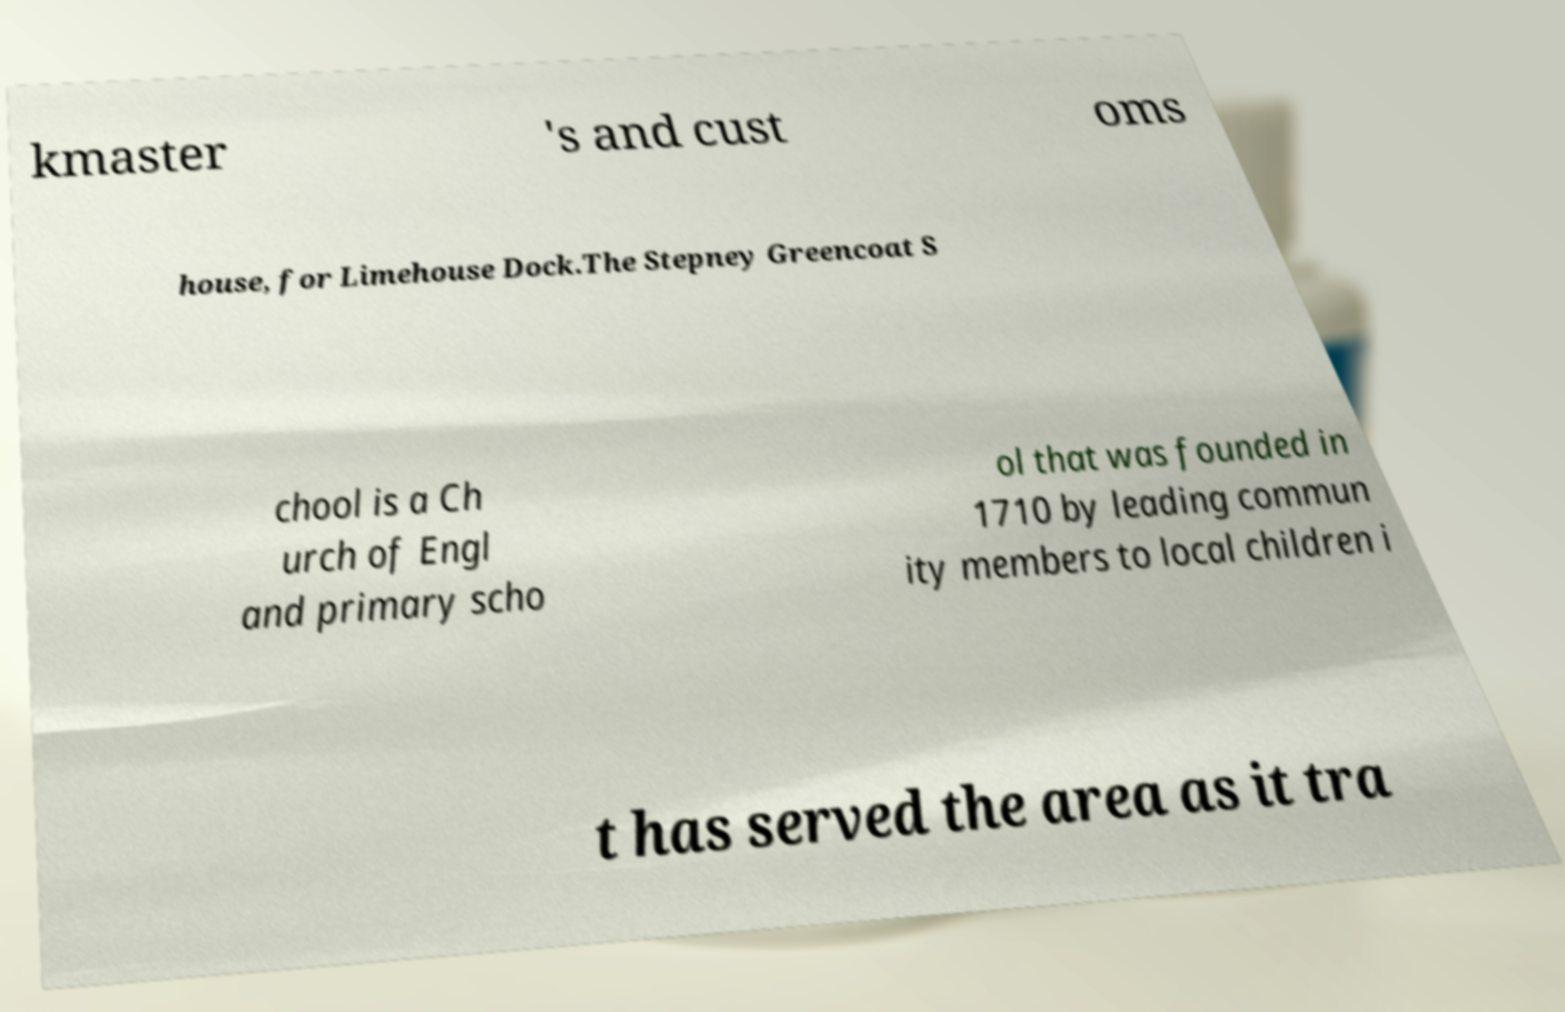Could you extract and type out the text from this image? kmaster 's and cust oms house, for Limehouse Dock.The Stepney Greencoat S chool is a Ch urch of Engl and primary scho ol that was founded in 1710 by leading commun ity members to local children i t has served the area as it tra 